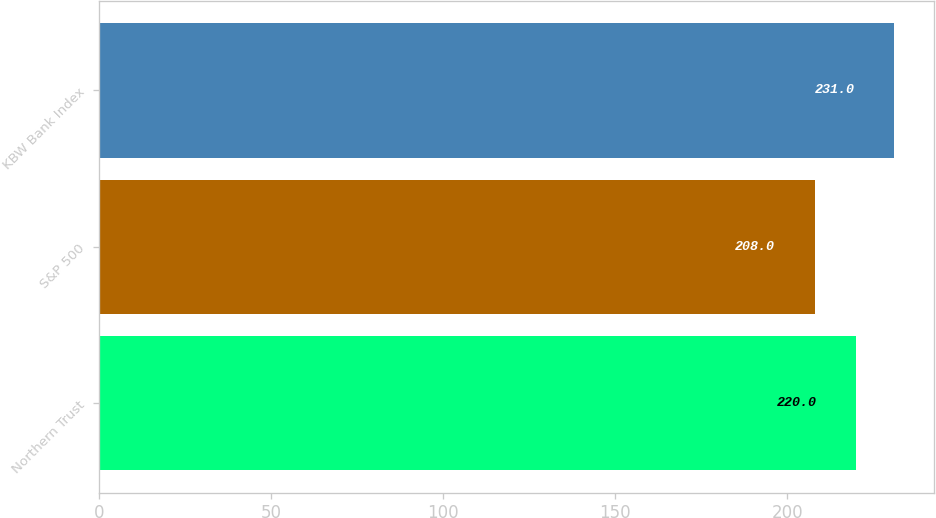Convert chart to OTSL. <chart><loc_0><loc_0><loc_500><loc_500><bar_chart><fcel>Northern Trust<fcel>S&P 500<fcel>KBW Bank Index<nl><fcel>220<fcel>208<fcel>231<nl></chart> 